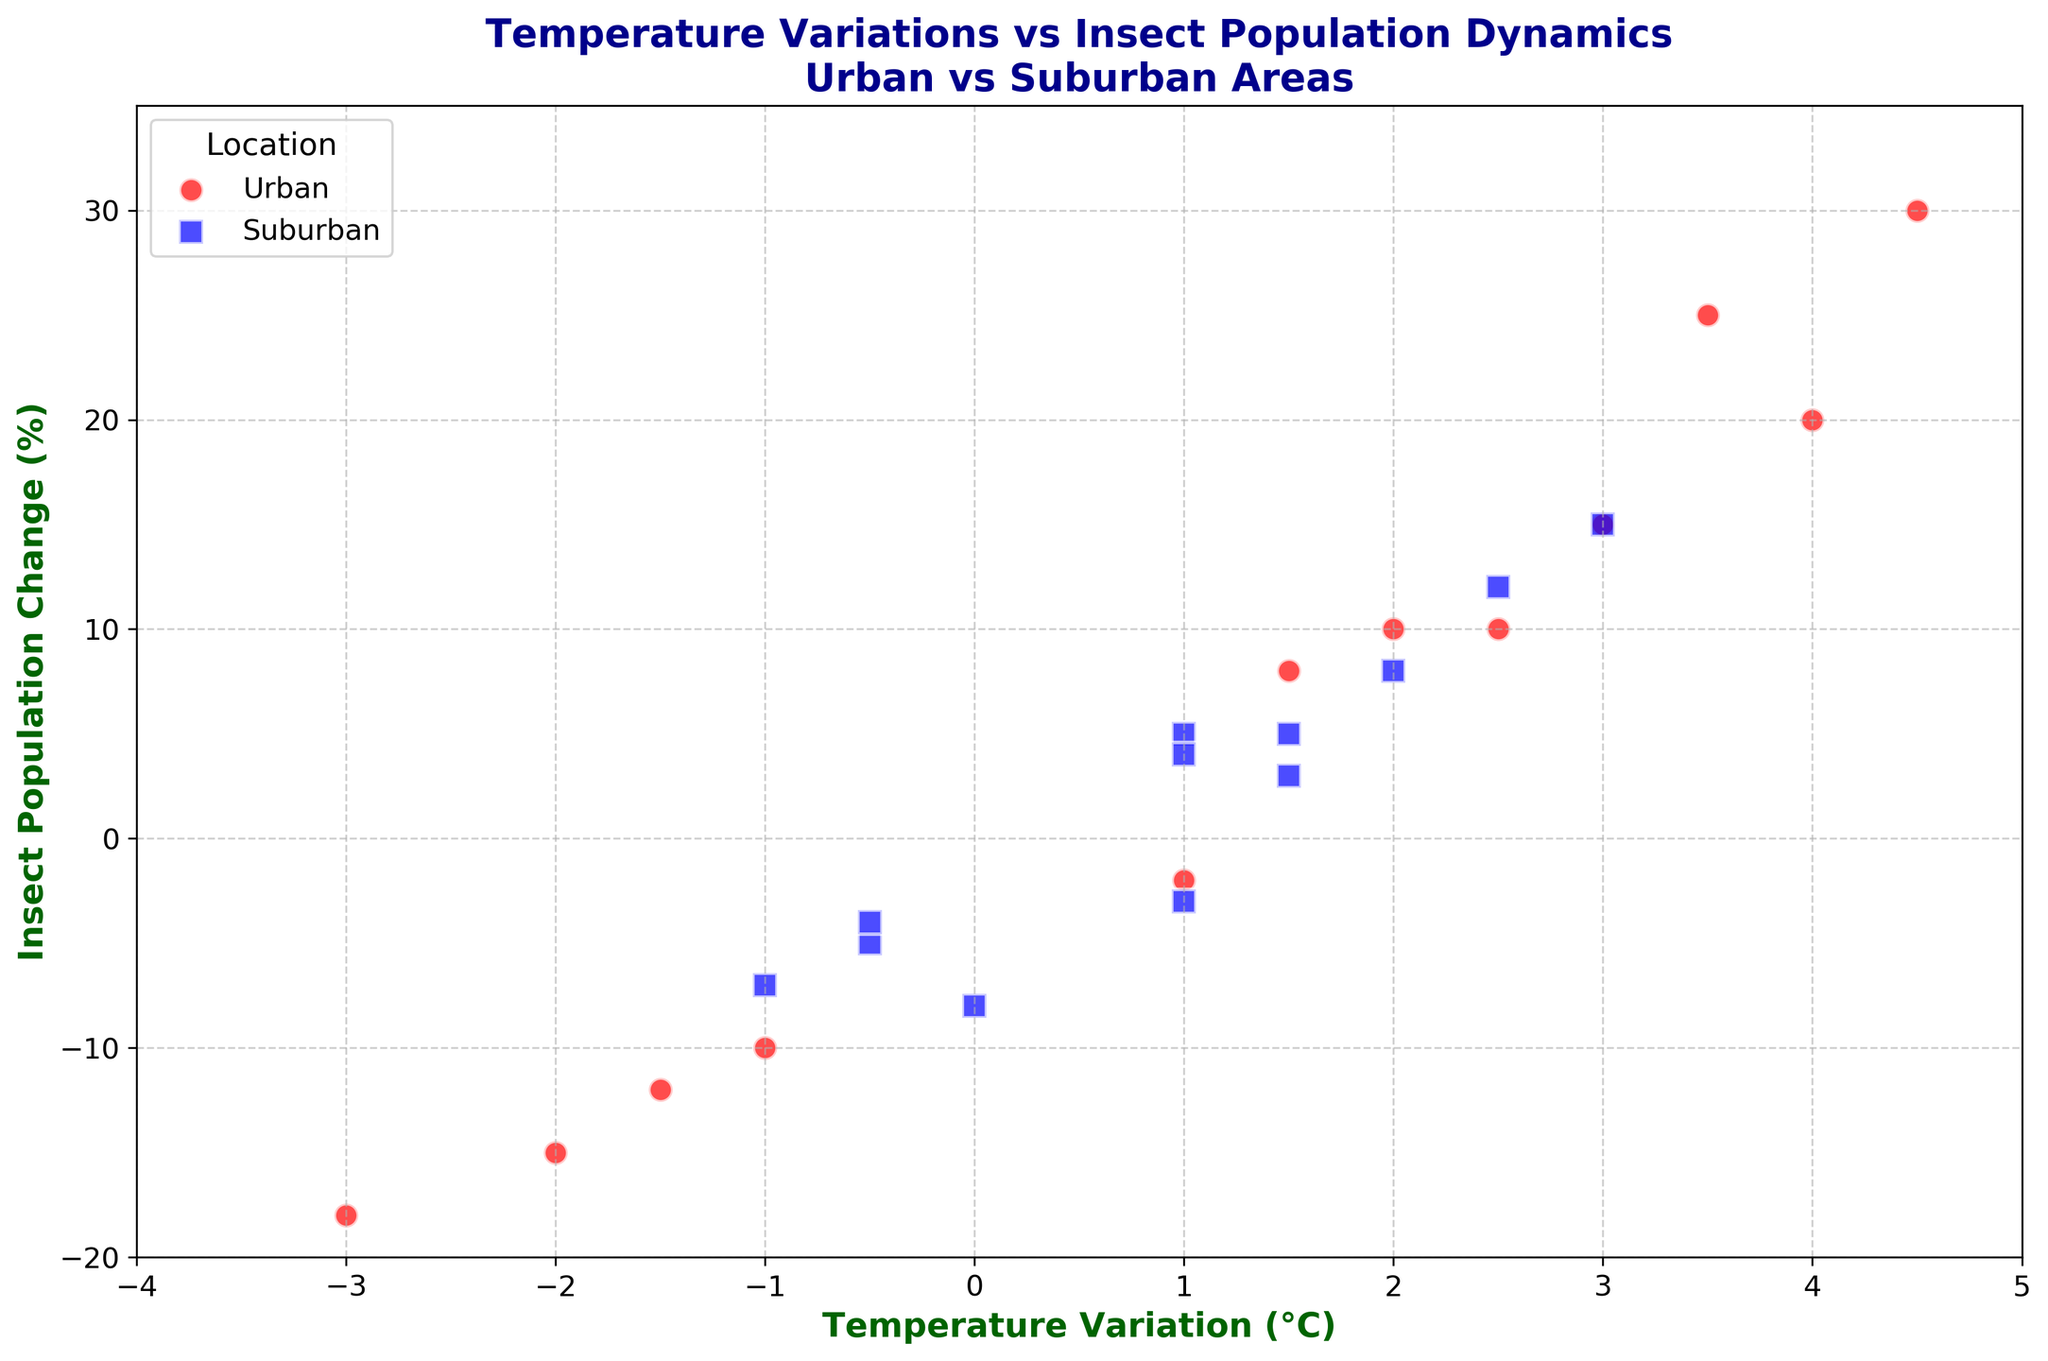Is there generally a higher insect population change in urban or suburban areas? By observing the scatter plot, we can see that most of the points representing "Urban" (in red) are located higher on the y-axis compared to the points for "Suburban" (in blue), indicating a higher insect population change in urban areas.
Answer: Urban What is the temperature variation and insect population change when the insect population in urban areas increased the most? Look for the highest point on the y-axis for the red dots. The highest point of the red dots indicates the insect population increased by 30% at a temperature variation of 4.5°C.
Answer: 4.5°C, 30% Is there a temperature variation where both urban and suburban areas experience a decrease in insect population? By examining the negative y values, we can see points for both "Urban" and "Suburban" at around -1.0°C and -0.5°C, indicating decreases in both locations.
Answer: Yes, at -1.0°C and -0.5°C Which month and location had the largest decrease in insect population, and what was the temperature variation? The largest decrease in insect population is the most negative y value, which is -18%. This occurs for an urban location with a -3.0°C temperature variation in November.
Answer: November in Urban, -3.0°C What are the temperature variations that resulted in a negative insect population change for both urban and suburban areas? Checking the scatter plot for negative y values (insect population change), the temperature variations with negative insect population change in both areas are -1.0°C, -2.0°C, -1.5°C, and -3.0°C.
Answer: -1.0°C, -2.0°C, -1.5°C, -3.0°C When the temperature variation is below zero, which location (urban or suburban) experiences a greater average decrease in insect population? Calculate the average of the insect population changes for negative temperature variations for both locations. For urban: (-10 + -15 + -12 + -18) / 4 = -13.75%. For suburban: (-5 + -8 + -4 + -7) / 4 = -6%. Therefore, urban areas experience a greater average decrease.
Answer: Urban At which temperature variations do both urban and suburban areas experience a positive insect population change, and what are the insect population changes? Look for positive y values for both locations at the same x values. These temperature variations are 1.0°C and 2.5°C. Insect population changes are (15%, 5%) at 1.0°C and (10%, 12%) at 2.5°C.
Answer: At 1.0°C: 15%, 5%; at 2.5°C: 10%, 12% Which temperature variation resulted in more than a 20% increase in insect population in urban areas? Find the red dots with y values over 20%. Temperature variations resulting in more than a 20% increase in insect population in urban areas are 4.0°C (20%), 3.5°C (25%), and 4.5°C (30%).
Answer: 4.0°C, 3.5°C, 4.5°C Calculate the average insect population change for both urban and suburban areas when the temperature variation is positive. For positive temperature variations, average changes are: Urban: (10 + 15 + 20 + 25 + 10 + 30 + 8) / 7 = 16.9%. Suburban: (5 + (-3) + 8 + 3 + 5 + 12 + 15 + 4) / 8 = 6.12%.
Answer: Urban: 16.9%, Suburban: 6.12% 